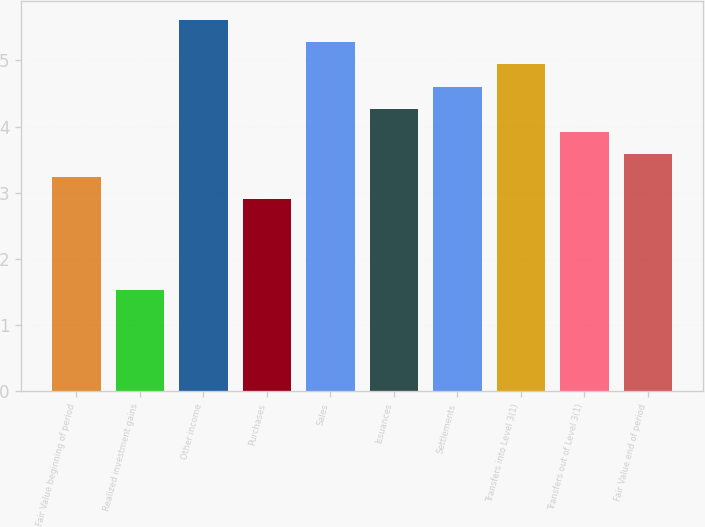Convert chart. <chart><loc_0><loc_0><loc_500><loc_500><bar_chart><fcel>Fair Value beginning of period<fcel>Realized investment gains<fcel>Other income<fcel>Purchases<fcel>Sales<fcel>Issuances<fcel>Settlements<fcel>Transfers into Level 3(1)<fcel>Transfers out of Level 3(1)<fcel>Fair Value end of period<nl><fcel>3.24<fcel>1.53<fcel>5.62<fcel>2.9<fcel>5.28<fcel>4.26<fcel>4.6<fcel>4.94<fcel>3.92<fcel>3.58<nl></chart> 